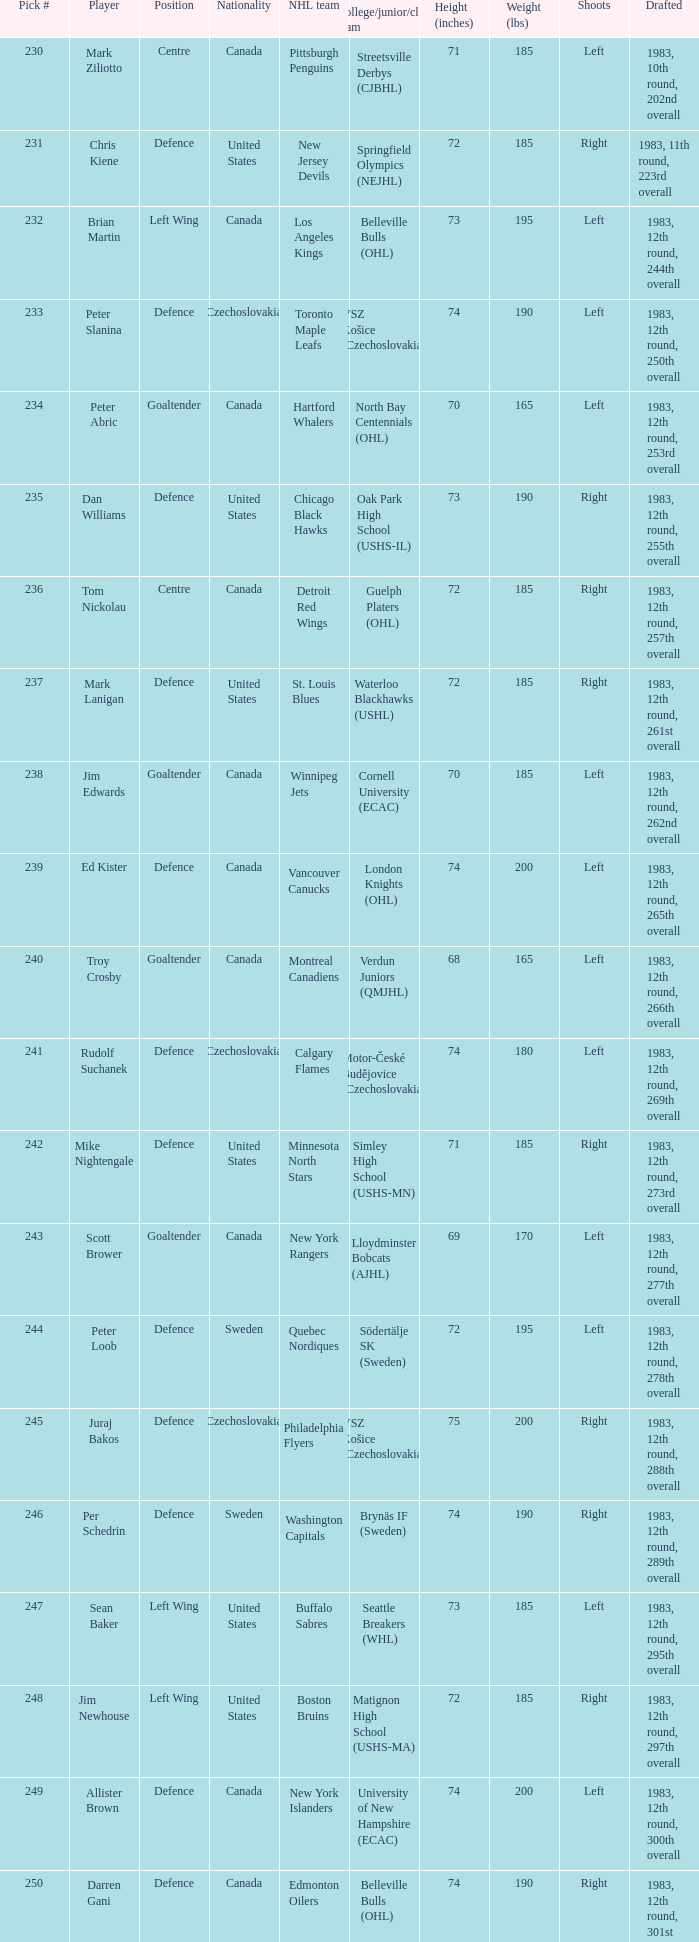Which draft number did the new jersey devils get? 231.0. 